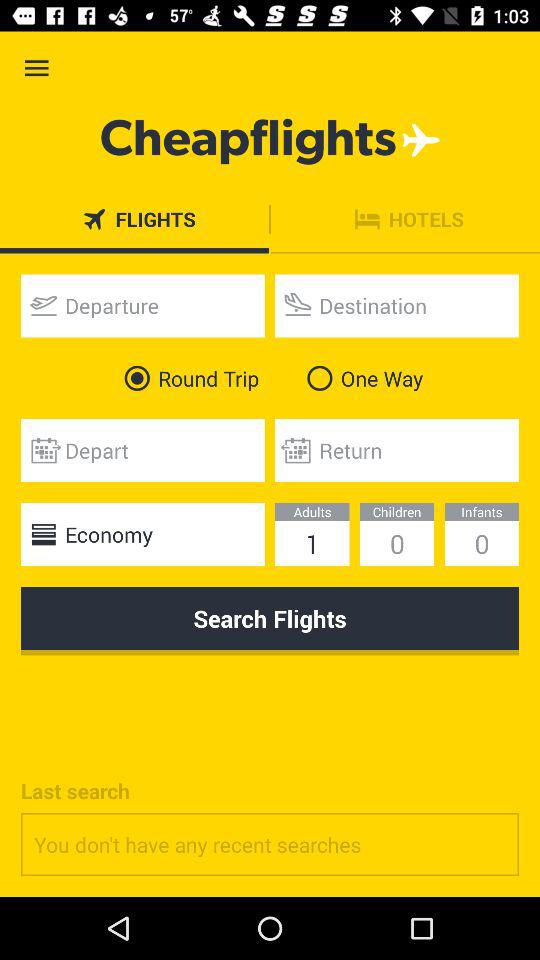What tab is selected? The selected tab is "FLIGHTS". 